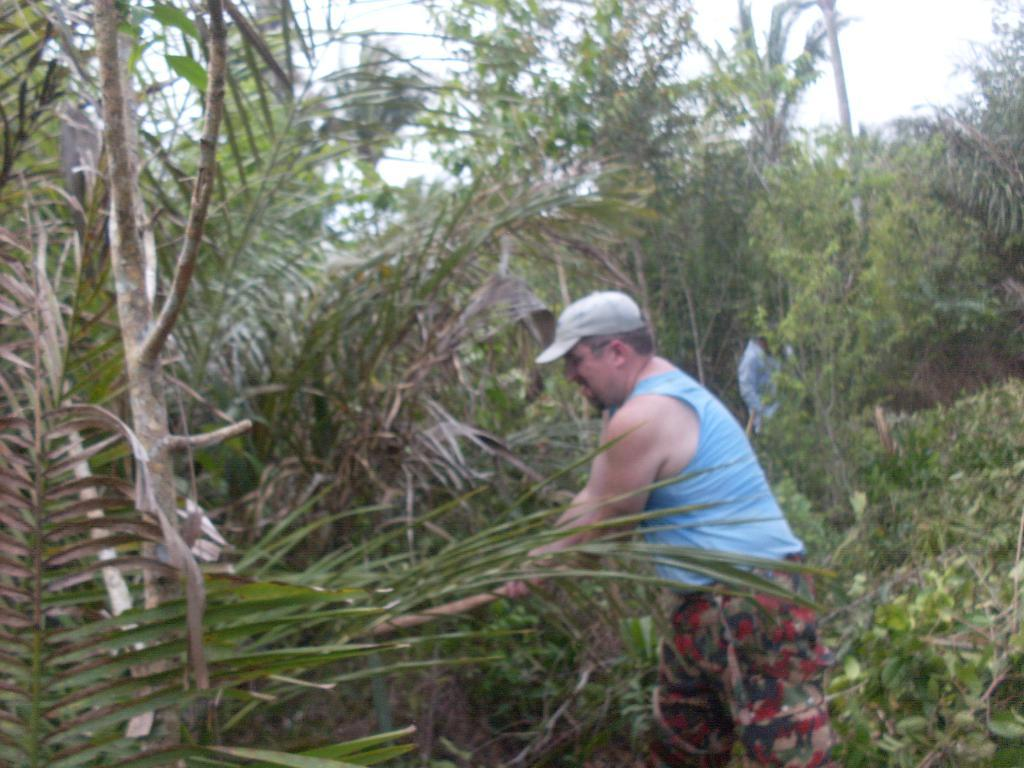What is the man in the image doing? The man is standing in the image. What is the man holding in the image? The man is holding an object. Can you describe the person behind the man? There is a person at the back of the man. What type of natural environment is visible in the image? Trees are visible in the image. What is visible at the top of the image? The sky is visible at the top of the image. What type of lip can be seen on the object the man is holding in the image? There is no lip present on the object the man is holding in the image. How much dirt is visible on the trees in the image? There is no dirt visible on the trees in the image; they appear to be clean and green. 